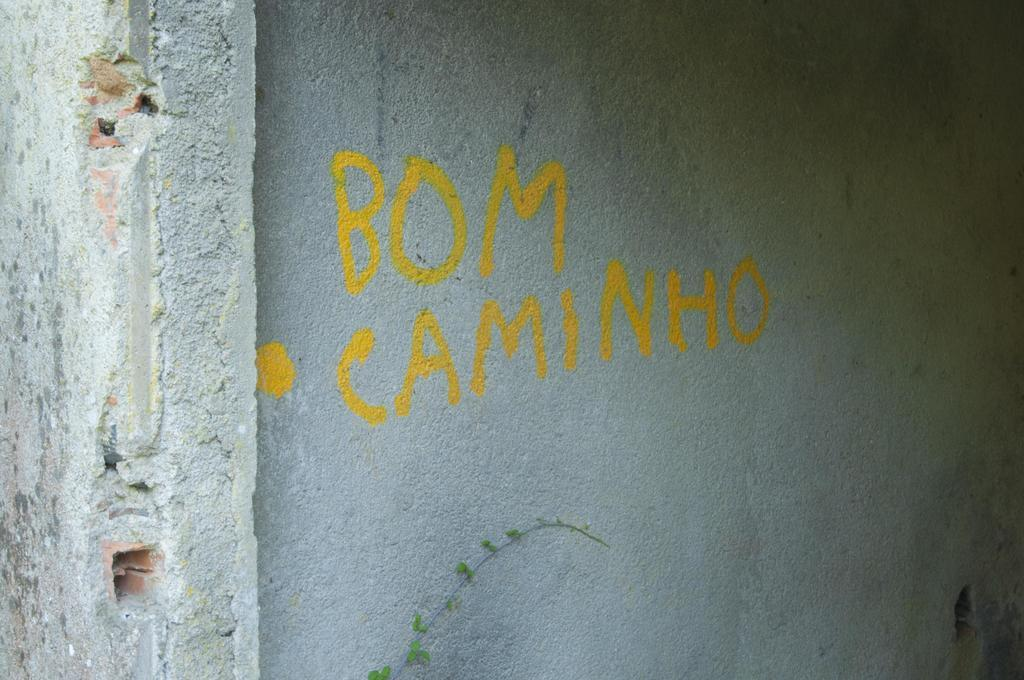What type of structure can be seen in the image? There is a wall and a pillar in the image. What is written or depicted on the wall? There is text on the wall in the image. What part of a plant is visible at the bottom of the image? There is a plant's stem at the bottom of the image. What type of birds can be seen flying around the pillar in the image? There are no birds visible in the image; it only features a wall, a pillar, text on the wall, and a plant's stem. What type of ink is used for the text on the wall? The type of ink used for the text on the wall cannot be determined from the image alone. 